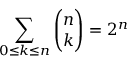Convert formula to latex. <formula><loc_0><loc_0><loc_500><loc_500>\sum _ { 0 \leq { k } \leq { n } } { \binom { n } { k } } = 2 ^ { n }</formula> 